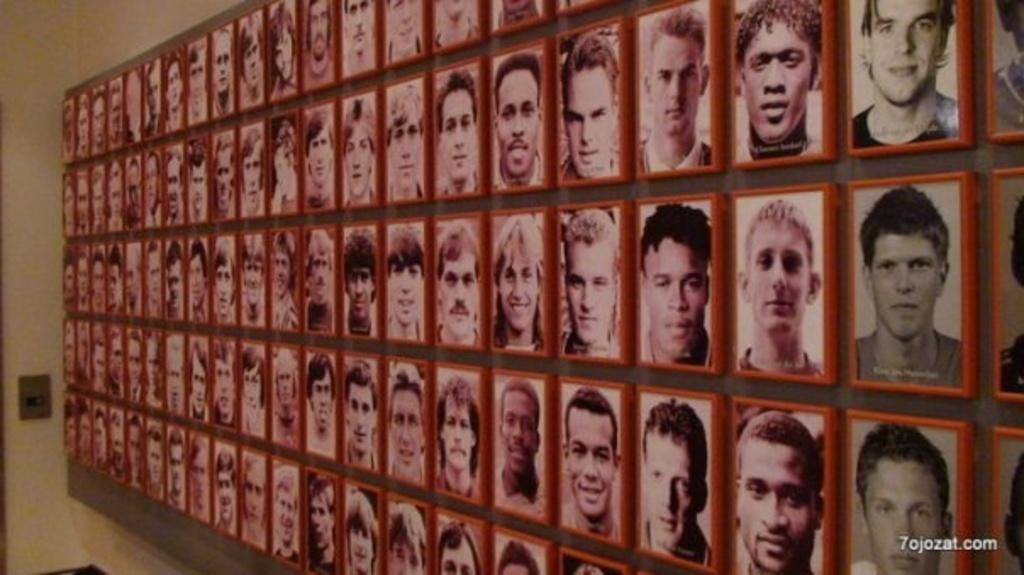What can be seen on the wall in the image? There are photos of different persons on the wall. Is there any additional information about the image itself? Yes, there is a watermark in the bottom right corner of the image. Where is the ant located in the image? There is no ant present in the image. Can you describe the girl in the image? There is no girl present in the image; it only features photos of different persons on the wall. 